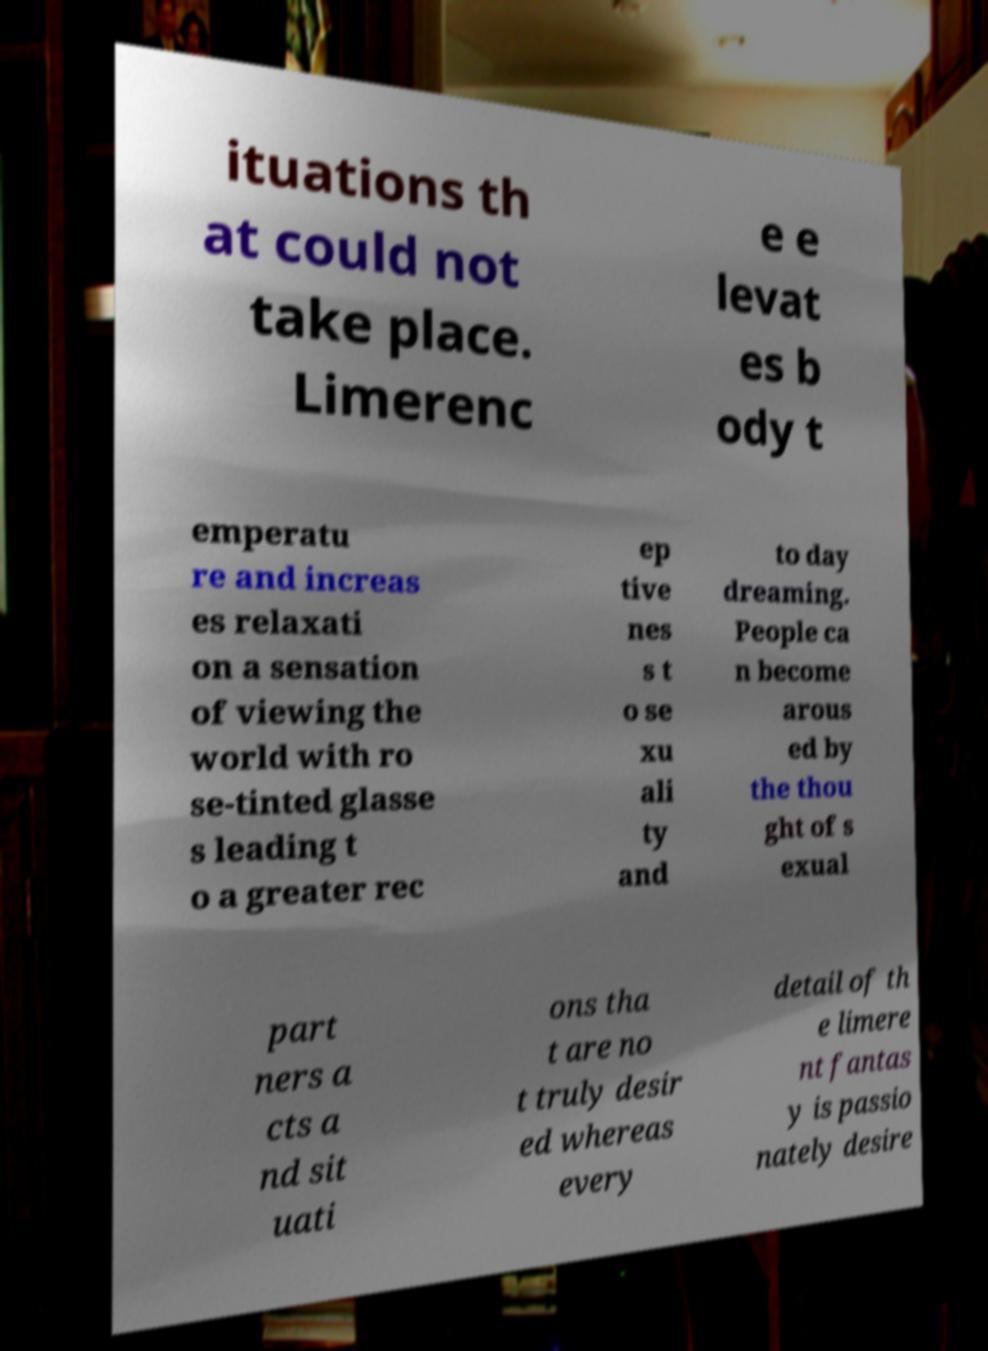Please identify and transcribe the text found in this image. ituations th at could not take place. Limerenc e e levat es b ody t emperatu re and increas es relaxati on a sensation of viewing the world with ro se-tinted glasse s leading t o a greater rec ep tive nes s t o se xu ali ty and to day dreaming. People ca n become arous ed by the thou ght of s exual part ners a cts a nd sit uati ons tha t are no t truly desir ed whereas every detail of th e limere nt fantas y is passio nately desire 